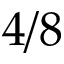Convert formula to latex. <formula><loc_0><loc_0><loc_500><loc_500>4 / 8</formula> 